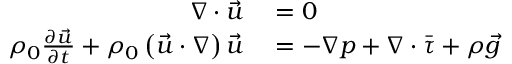<formula> <loc_0><loc_0><loc_500><loc_500>\begin{array} { r l } { \nabla \cdot \vec { u } } & = 0 } \\ { \rho _ { 0 } \frac { \partial \vec { u } } { \partial t } + \rho _ { 0 } \left ( \vec { u } \cdot \nabla \right ) \vec { u } } & = - \nabla p + \nabla \cdot \bar { \tau } + \rho \vec { g } } \end{array}</formula> 